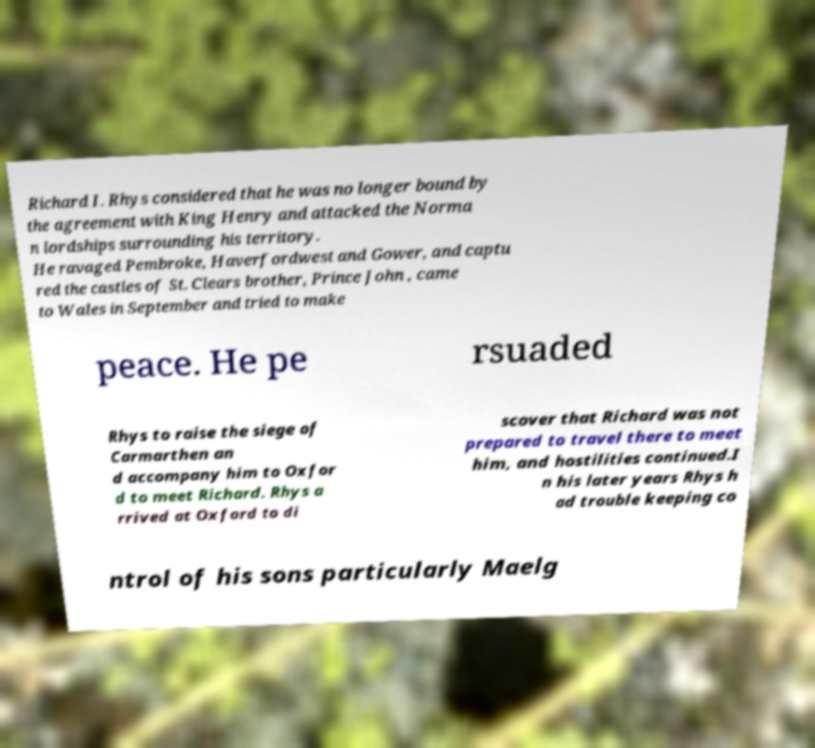For documentation purposes, I need the text within this image transcribed. Could you provide that? Richard I. Rhys considered that he was no longer bound by the agreement with King Henry and attacked the Norma n lordships surrounding his territory. He ravaged Pembroke, Haverfordwest and Gower, and captu red the castles of St. Clears brother, Prince John , came to Wales in September and tried to make peace. He pe rsuaded Rhys to raise the siege of Carmarthen an d accompany him to Oxfor d to meet Richard. Rhys a rrived at Oxford to di scover that Richard was not prepared to travel there to meet him, and hostilities continued.I n his later years Rhys h ad trouble keeping co ntrol of his sons particularly Maelg 